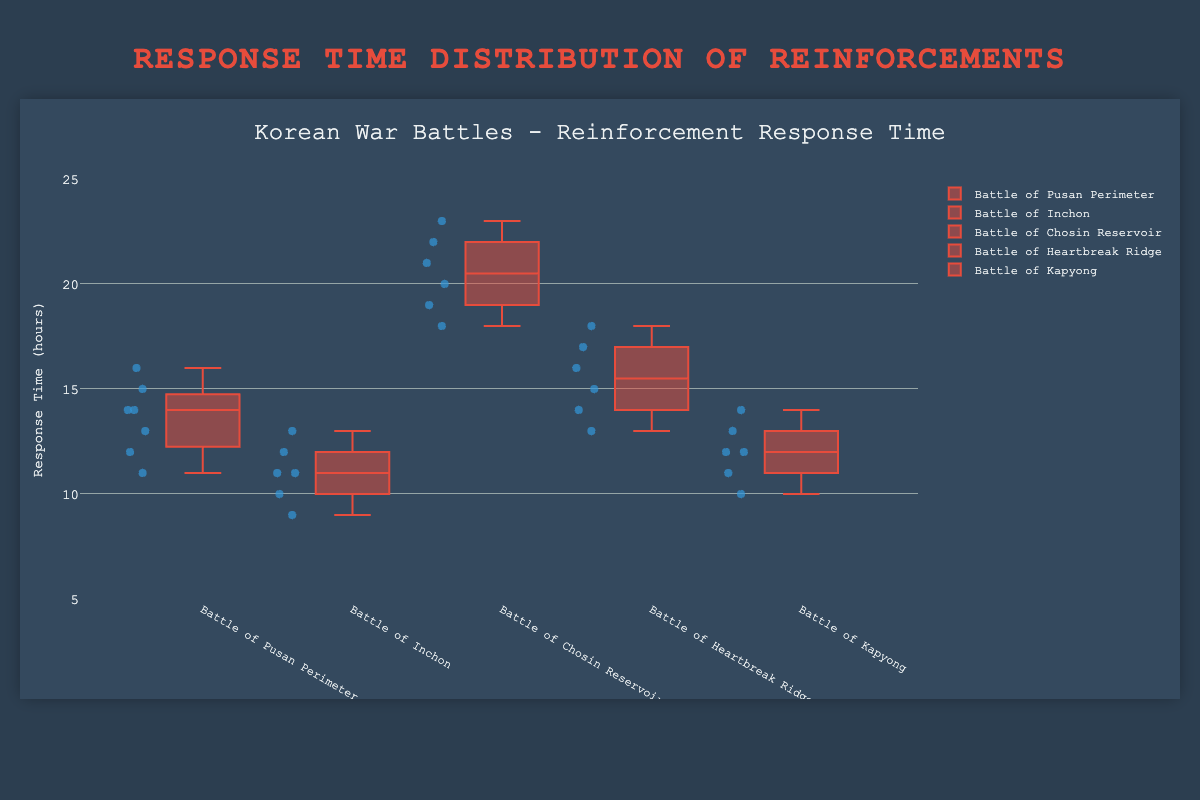What is the title of the chart? The title of the chart is displayed at the top and reads "Korean War Battles - Reinforcement Response Time".
Answer: Korean War Battles - Reinforcement Response Time How many battles are represented in the figure? The horizontal axis shows the names of the battles, which are "Battle of Pusan Perimeter", "Battle of Inchon", "Battle of Chosin Reservoir", "Battle of Heartbreak Ridge", and "Battle of Kapyong". Counting these names gives us five battles.
Answer: Five Which battle has the longest median response time? The median response time is represented by the line inside the box of each plot. The "Battle of Chosin Reservoir" box plot has the longest median line compared to the other battles.
Answer: Battle of Chosin Reservoir What is the range of response times for the Battle of Inchon? The range of response times is indicated by the bottommost and topmost points (including outliers) of the box plot for that battle. For the "Battle of Inchon", these points are 9 and 13.
Answer: 9 to 13 How does the interquartile range (IQR) of the Battle of Heartbreak Ridge compare to that of the Battle of Pusan Perimeter? The IQR is the length of the box itself (the distance from the lower quartile to the upper quartile). The box for "Battle of Heartbreak Ridge" is larger compared to that of the "Battle of Pusan Perimeter", indicating a larger IQR.
Answer: Battle of Heartbreak Ridge has a larger IQR Which battle has the smallest variation in response times? Variation in response times can be seen by the width of the box plot and the spread of the points. The "Battle of Inchon" has the smallest and most compact box plot, indicating the smallest variation.
Answer: Battle of Inchon What is the median response time for the Battle of Kapyong? The median value is indicated by the line inside the box plot. For the "Battle of Kapyong", the median line is at 12.
Answer: 12 Which battle has the highest maximum response time? The highest maximum response time is the topmost point of the entire vertical axis range for each box plot. The "Battle of Chosin Reservoir" has the highest maximum point at 23.
Answer: Battle of Chosin Reservoir 